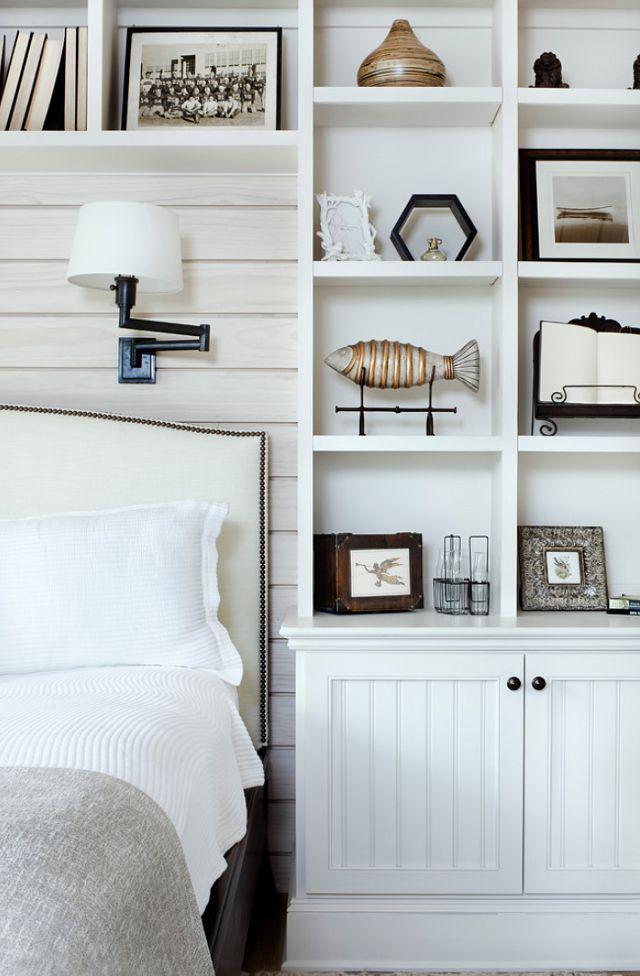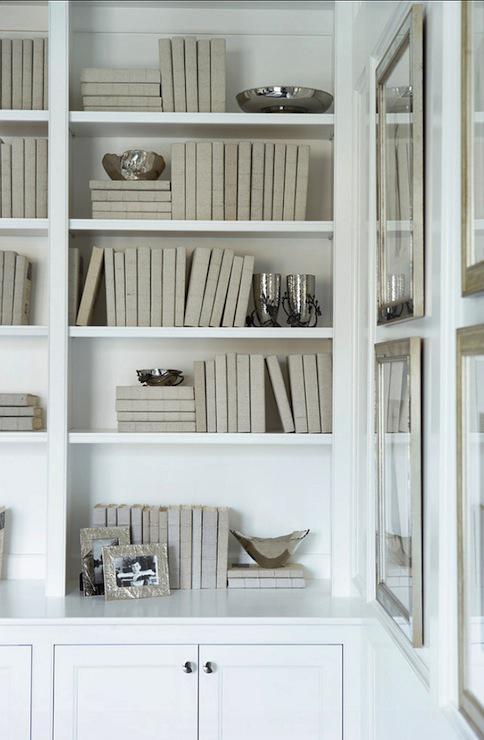The first image is the image on the left, the second image is the image on the right. Given the left and right images, does the statement "There is exactly one chair in the image on the left." hold true? Answer yes or no. No. 